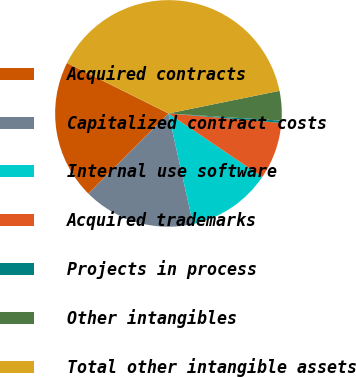<chart> <loc_0><loc_0><loc_500><loc_500><pie_chart><fcel>Acquired contracts<fcel>Capitalized contract costs<fcel>Internal use software<fcel>Acquired trademarks<fcel>Projects in process<fcel>Other intangibles<fcel>Total other intangible assets<nl><fcel>19.88%<fcel>15.96%<fcel>12.05%<fcel>8.14%<fcel>0.31%<fcel>4.22%<fcel>39.45%<nl></chart> 